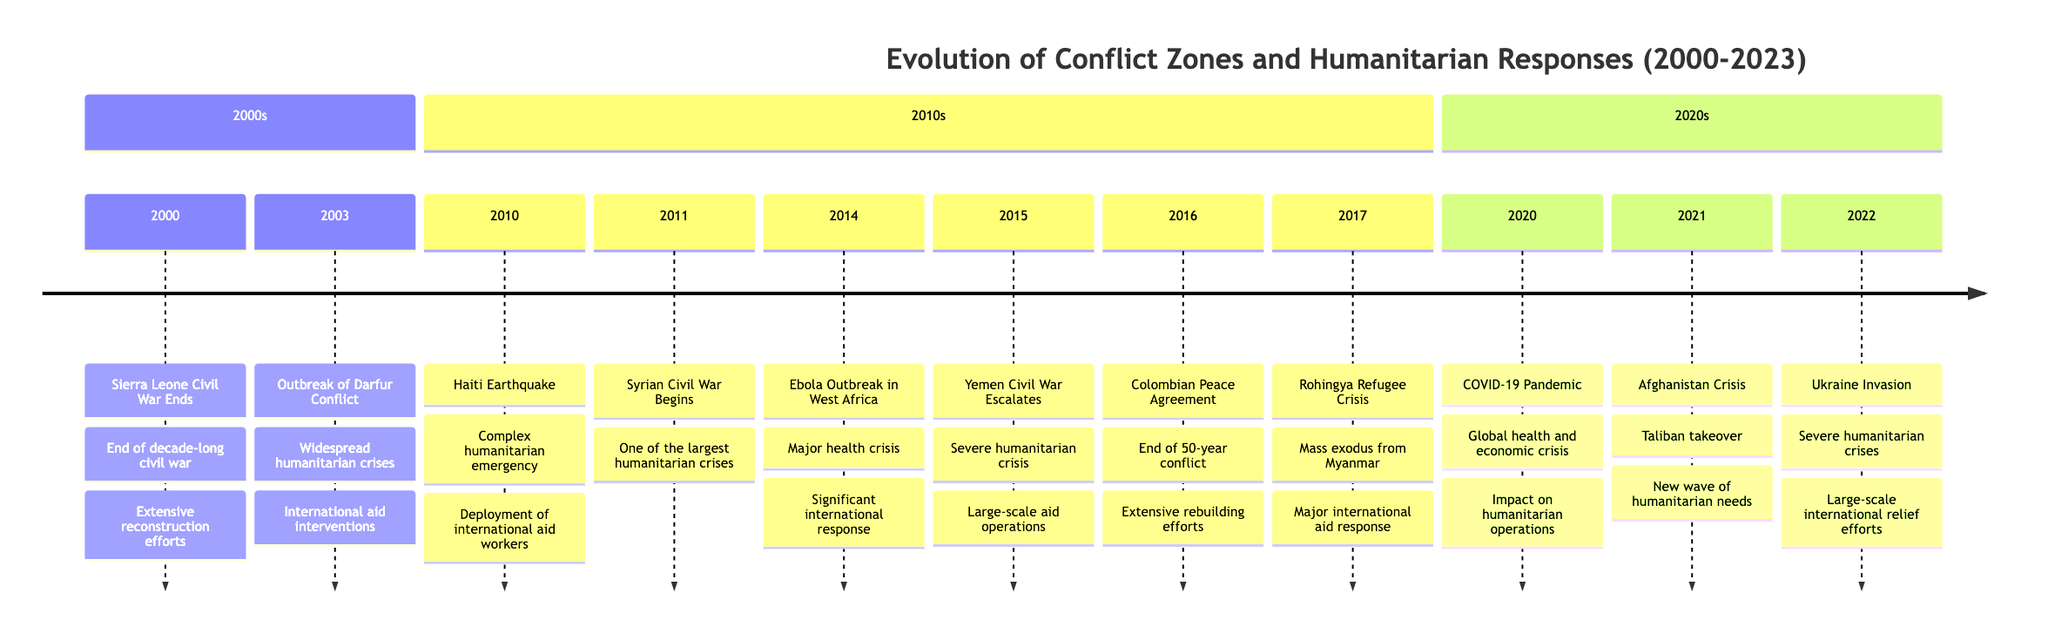What year did the Sierra Leone Civil War end? The timeline specifically states that the Sierra Leone Civil War ended in the year 2000.
Answer: 2000 What event marked the beginning of the Syrian Civil War? According to the timeline, the event that marked the beginning of the Syrian Civil War is labeled as "Syrian Civil War Begins" in 2011.
Answer: Syrian Civil War Begins How many major humanitarian crises are listed between 2010 and 2022? By counting each event labeled as a major humanitarian crisis between 2010 and 2022 on the timeline, we find that there are six crises mentioned.
Answer: 6 Which conflict has the earliest start date listed? The earliest conflict mentioned in the timeline is the Sierra Leone Civil War, which ended in the year 2000. Since no earlier event is listed in this context, the answer is based on the keyword "ends."
Answer: Sierra Leone Civil War What was the significant international health response event in 2014? The timeline indicates that in 2014, there was an "Ebola Outbreak in West Africa," which triggered a significant international health response.
Answer: Ebola Outbreak in West Africa What major humanitarian event happened in 2021? The timeline notes that in 2021, a significant event occurred referred to as the "Afghanistan Crisis."
Answer: Afghanistan Crisis Which humanitarian response marked the end of a 50-year conflict? The event that marked the end of a 50-year conflict according to the timeline is the "Colombian Peace Agreement" in 2016.
Answer: Colombian Peace Agreement After which year did the Rohingya Refugee Crisis occur? The Rohingya Refugee Crisis is recorded in 2017, which is one year after the Colombian Peace Agreement in 2016.
Answer: 2016 Which year saw both a severe humanitarian crisis and large-scale international relief efforts due to an invasion? The year 2022 saw the event of "Ukraine Invasion," which resulted in both a severe humanitarian crisis and international relief efforts, as stated in the timeline.
Answer: 2022 